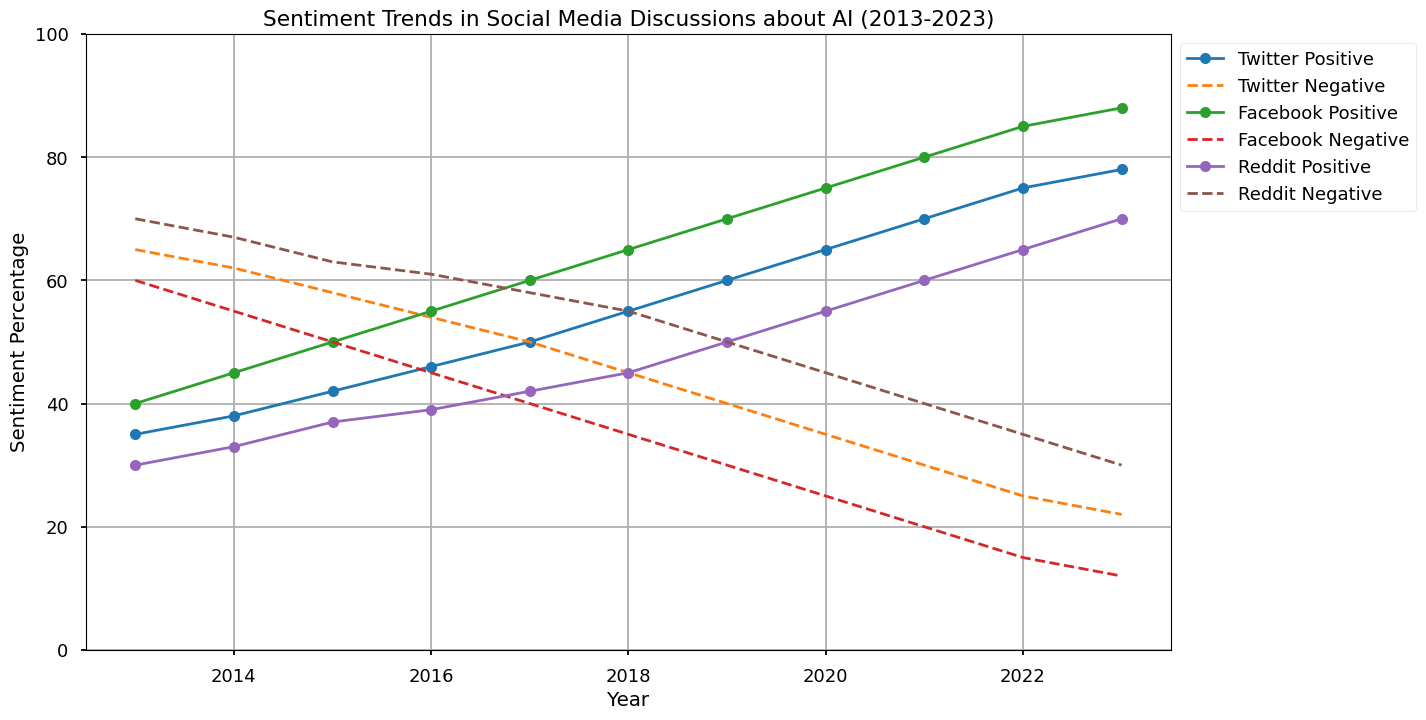What's the trend of positive sentiment on Twitter from 2013 to 2023? The positive sentiment on Twitter increases steadily from 35% in 2013 to 78% in 2023. We can see a consistent upward trend every year.
Answer: Steady increase In 2015, which platform had the highest positive sentiment? By looking at the positive sentiment lines for 2015, Facebook had the highest positive sentiment at 50%, compared to Twitter (42%) and Reddit (37%).
Answer: Facebook How did the negative sentiment on Reddit change from 2013 to 2023? The negative sentiment on Reddit decreased over the years from 70% in 2013 to 30% in 2023. The trend shows a continuous decline.
Answer: Decrease Which platform had the smallest change in positive sentiment from 2013 to 2014? By comparing the changes in positive sentiment for each platform between 2013 and 2014, Reddit had the smallest change, increasing only by 3% (from 30% to 33%), compared to Twitter (3%) and Facebook (5%).
Answer: Reddit In which year did Facebook see the largest increase in positive sentiment? The most significant jump in positive sentiment for Facebook is observed between 2014 and 2015, where it increased from 45% to 50%.
Answer: 2015 Between 2019 and 2020, which platform experienced the highest increase in positive sentiment? By comparing the positive sentiment lines between 2019 and 2020, Twitter had the highest increase, growing from 60% to 65%.
Answer: Twitter Which platform reached the highest positive sentiment in 2023? Looking at the positive sentiment figures for 2023, Facebook had the highest positive sentiment at 88%.
Answer: Facebook What's the average positive sentiment for Facebook from 2013 to 2023? The average positive sentiment for Facebook over these years can be calculated as follows: (40 + 45 + 50 + 55 + 60 + 65 + 70 + 75 + 80 + 85 + 88) / 11 = 68.18
Answer: 68.18 How much did the negative sentiment decrease on Facebook from 2013 to 2023? The negative sentiment on Facebook decreased from 60% in 2013 to 12% in 2023, giving a total decrease of 48%.
Answer: 48% In which year did all platforms have an equal negative sentiment percentage? By checking the negative sentiment lines, it can be seen that in 2015 all platforms had negative sentiments summing to 50%.
Answer: 2015 